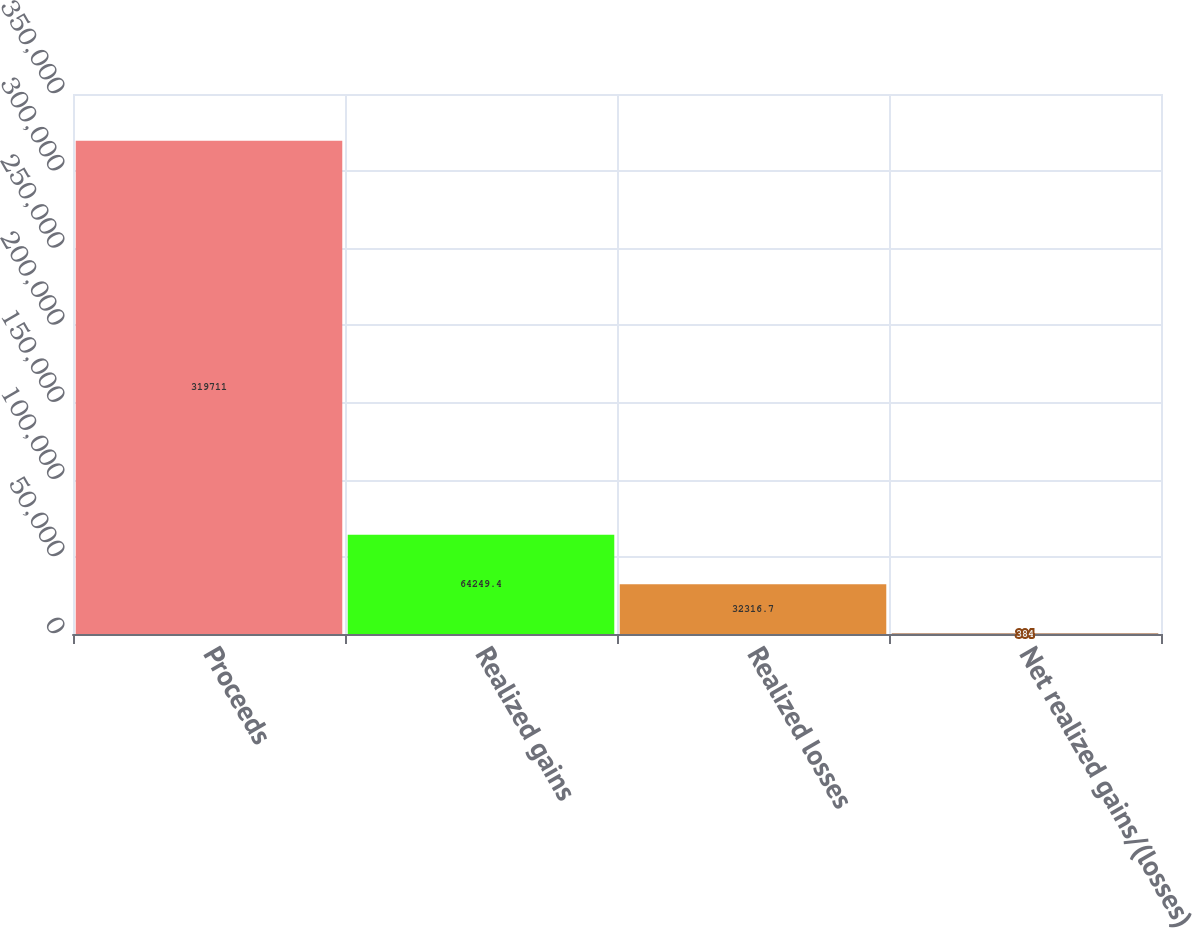<chart> <loc_0><loc_0><loc_500><loc_500><bar_chart><fcel>Proceeds<fcel>Realized gains<fcel>Realized losses<fcel>Net realized gains/(losses)<nl><fcel>319711<fcel>64249.4<fcel>32316.7<fcel>384<nl></chart> 